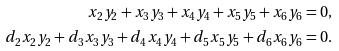<formula> <loc_0><loc_0><loc_500><loc_500>x _ { 2 } y _ { 2 } + x _ { 3 } y _ { 3 } + x _ { 4 } y _ { 4 } + x _ { 5 } y _ { 5 } + x _ { 6 } y _ { 6 } & = 0 , \\ d _ { 2 } x _ { 2 } y _ { 2 } + d _ { 3 } x _ { 3 } y _ { 3 } + d _ { 4 } x _ { 4 } y _ { 4 } + d _ { 5 } x _ { 5 } y _ { 5 } + d _ { 6 } x _ { 6 } y _ { 6 } & = 0 .</formula> 